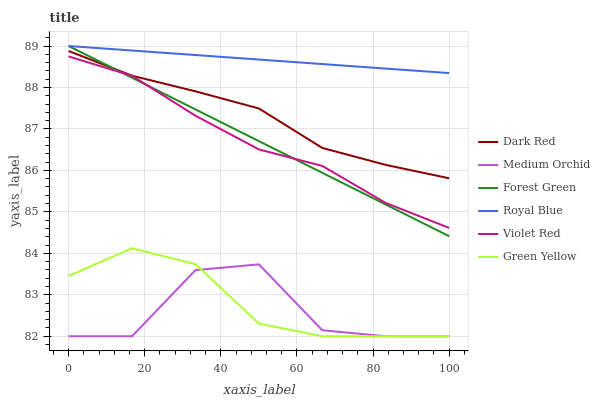Does Medium Orchid have the minimum area under the curve?
Answer yes or no. Yes. Does Royal Blue have the maximum area under the curve?
Answer yes or no. Yes. Does Dark Red have the minimum area under the curve?
Answer yes or no. No. Does Dark Red have the maximum area under the curve?
Answer yes or no. No. Is Forest Green the smoothest?
Answer yes or no. Yes. Is Medium Orchid the roughest?
Answer yes or no. Yes. Is Dark Red the smoothest?
Answer yes or no. No. Is Dark Red the roughest?
Answer yes or no. No. Does Medium Orchid have the lowest value?
Answer yes or no. Yes. Does Dark Red have the lowest value?
Answer yes or no. No. Does Forest Green have the highest value?
Answer yes or no. Yes. Does Dark Red have the highest value?
Answer yes or no. No. Is Medium Orchid less than Dark Red?
Answer yes or no. Yes. Is Dark Red greater than Medium Orchid?
Answer yes or no. Yes. Does Forest Green intersect Dark Red?
Answer yes or no. Yes. Is Forest Green less than Dark Red?
Answer yes or no. No. Is Forest Green greater than Dark Red?
Answer yes or no. No. Does Medium Orchid intersect Dark Red?
Answer yes or no. No. 